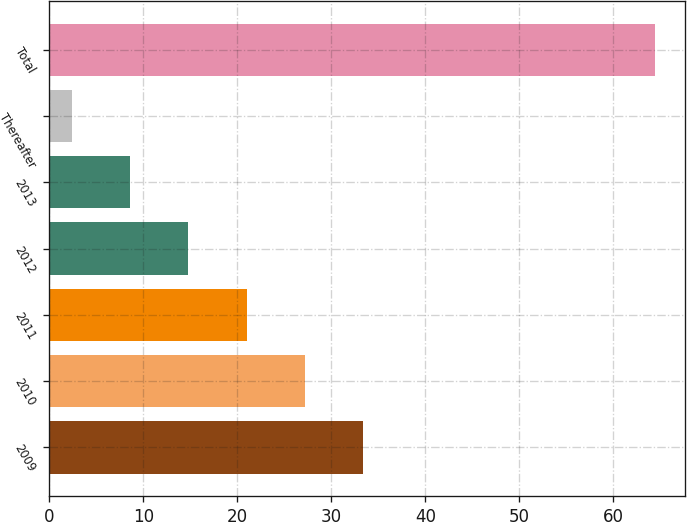Convert chart. <chart><loc_0><loc_0><loc_500><loc_500><bar_chart><fcel>2009<fcel>2010<fcel>2011<fcel>2012<fcel>2013<fcel>Thereafter<fcel>Total<nl><fcel>33.4<fcel>27.2<fcel>21<fcel>14.8<fcel>8.6<fcel>2.4<fcel>64.4<nl></chart> 